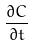Convert formula to latex. <formula><loc_0><loc_0><loc_500><loc_500>\frac { \partial C } { \partial t }</formula> 